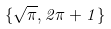Convert formula to latex. <formula><loc_0><loc_0><loc_500><loc_500>\{ \sqrt { \pi } , 2 \pi + 1 \}</formula> 